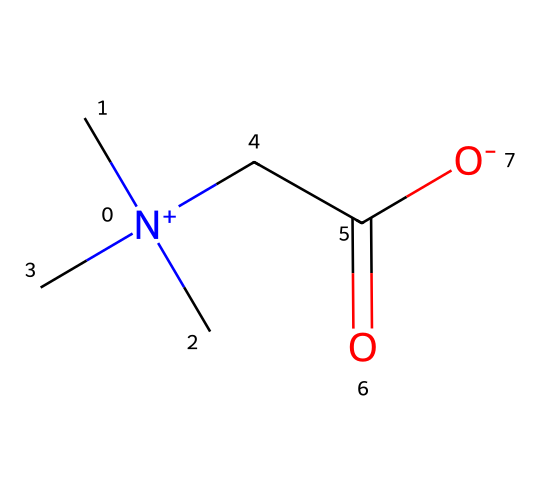What is the functional group present in this molecule? The molecule contains a carboxylic acid functional group, as indicated by the -COOH part in the SMILES representation.
Answer: carboxylic acid How many nitrogen atoms are in this structure? By examining the SMILES, there is one nitrogen atom represented by [N+].
Answer: one What type of surfactant is represented by this structure? This structure represents a cationic surfactant due to the positively charged nitrogen atom ([N+]).
Answer: cationic What is the total number of carbon atoms in this chemical? The carbon atoms can be counted from the SMILES: there are three from the N(C)(C)(C) part and one from the CC(=O) part, totaling four.
Answer: four How many hydrogen atoms are likely associated with this molecule? To determine the number of hydrogen atoms, we consider the valency of carbon (4) and the nitrogen (3), along with the structure. From the arrangements in the SMILES, we estimate there are 10 hydrogen atoms.
Answer: ten What role do betaines play in herbal cosmetics? Betaines are recognized for their surfactant properties, helping to create lather and improve foaming in herbal cosmetics.
Answer: surfactant properties 